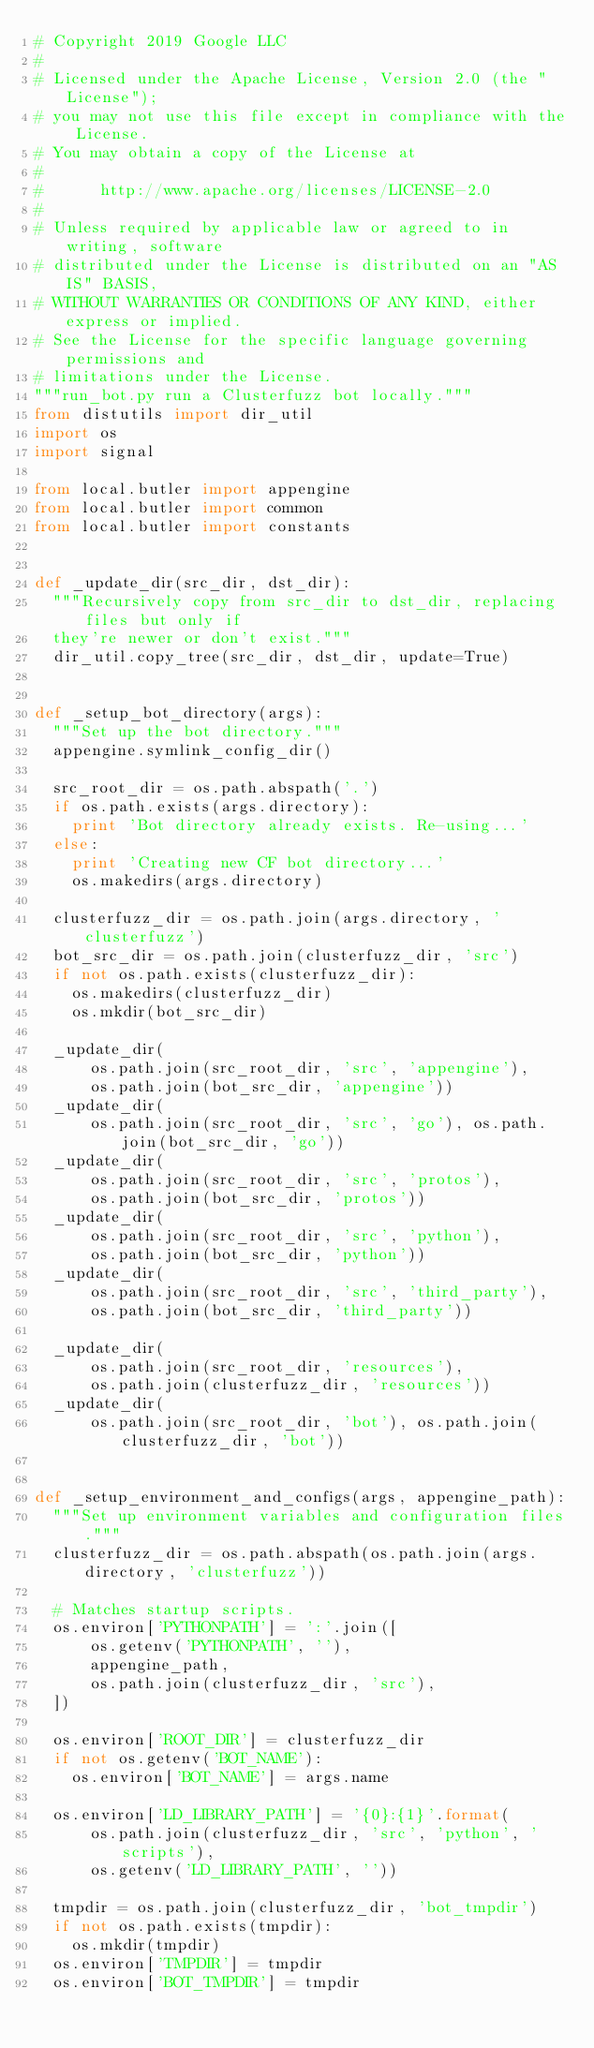Convert code to text. <code><loc_0><loc_0><loc_500><loc_500><_Python_># Copyright 2019 Google LLC
#
# Licensed under the Apache License, Version 2.0 (the "License");
# you may not use this file except in compliance with the License.
# You may obtain a copy of the License at
#
#      http://www.apache.org/licenses/LICENSE-2.0
#
# Unless required by applicable law or agreed to in writing, software
# distributed under the License is distributed on an "AS IS" BASIS,
# WITHOUT WARRANTIES OR CONDITIONS OF ANY KIND, either express or implied.
# See the License for the specific language governing permissions and
# limitations under the License.
"""run_bot.py run a Clusterfuzz bot locally."""
from distutils import dir_util
import os
import signal

from local.butler import appengine
from local.butler import common
from local.butler import constants


def _update_dir(src_dir, dst_dir):
  """Recursively copy from src_dir to dst_dir, replacing files but only if
  they're newer or don't exist."""
  dir_util.copy_tree(src_dir, dst_dir, update=True)


def _setup_bot_directory(args):
  """Set up the bot directory."""
  appengine.symlink_config_dir()

  src_root_dir = os.path.abspath('.')
  if os.path.exists(args.directory):
    print 'Bot directory already exists. Re-using...'
  else:
    print 'Creating new CF bot directory...'
    os.makedirs(args.directory)

  clusterfuzz_dir = os.path.join(args.directory, 'clusterfuzz')
  bot_src_dir = os.path.join(clusterfuzz_dir, 'src')
  if not os.path.exists(clusterfuzz_dir):
    os.makedirs(clusterfuzz_dir)
    os.mkdir(bot_src_dir)

  _update_dir(
      os.path.join(src_root_dir, 'src', 'appengine'),
      os.path.join(bot_src_dir, 'appengine'))
  _update_dir(
      os.path.join(src_root_dir, 'src', 'go'), os.path.join(bot_src_dir, 'go'))
  _update_dir(
      os.path.join(src_root_dir, 'src', 'protos'),
      os.path.join(bot_src_dir, 'protos'))
  _update_dir(
      os.path.join(src_root_dir, 'src', 'python'),
      os.path.join(bot_src_dir, 'python'))
  _update_dir(
      os.path.join(src_root_dir, 'src', 'third_party'),
      os.path.join(bot_src_dir, 'third_party'))

  _update_dir(
      os.path.join(src_root_dir, 'resources'),
      os.path.join(clusterfuzz_dir, 'resources'))
  _update_dir(
      os.path.join(src_root_dir, 'bot'), os.path.join(clusterfuzz_dir, 'bot'))


def _setup_environment_and_configs(args, appengine_path):
  """Set up environment variables and configuration files."""
  clusterfuzz_dir = os.path.abspath(os.path.join(args.directory, 'clusterfuzz'))

  # Matches startup scripts.
  os.environ['PYTHONPATH'] = ':'.join([
      os.getenv('PYTHONPATH', ''),
      appengine_path,
      os.path.join(clusterfuzz_dir, 'src'),
  ])

  os.environ['ROOT_DIR'] = clusterfuzz_dir
  if not os.getenv('BOT_NAME'):
    os.environ['BOT_NAME'] = args.name

  os.environ['LD_LIBRARY_PATH'] = '{0}:{1}'.format(
      os.path.join(clusterfuzz_dir, 'src', 'python', 'scripts'),
      os.getenv('LD_LIBRARY_PATH', ''))

  tmpdir = os.path.join(clusterfuzz_dir, 'bot_tmpdir')
  if not os.path.exists(tmpdir):
    os.mkdir(tmpdir)
  os.environ['TMPDIR'] = tmpdir
  os.environ['BOT_TMPDIR'] = tmpdir
</code> 